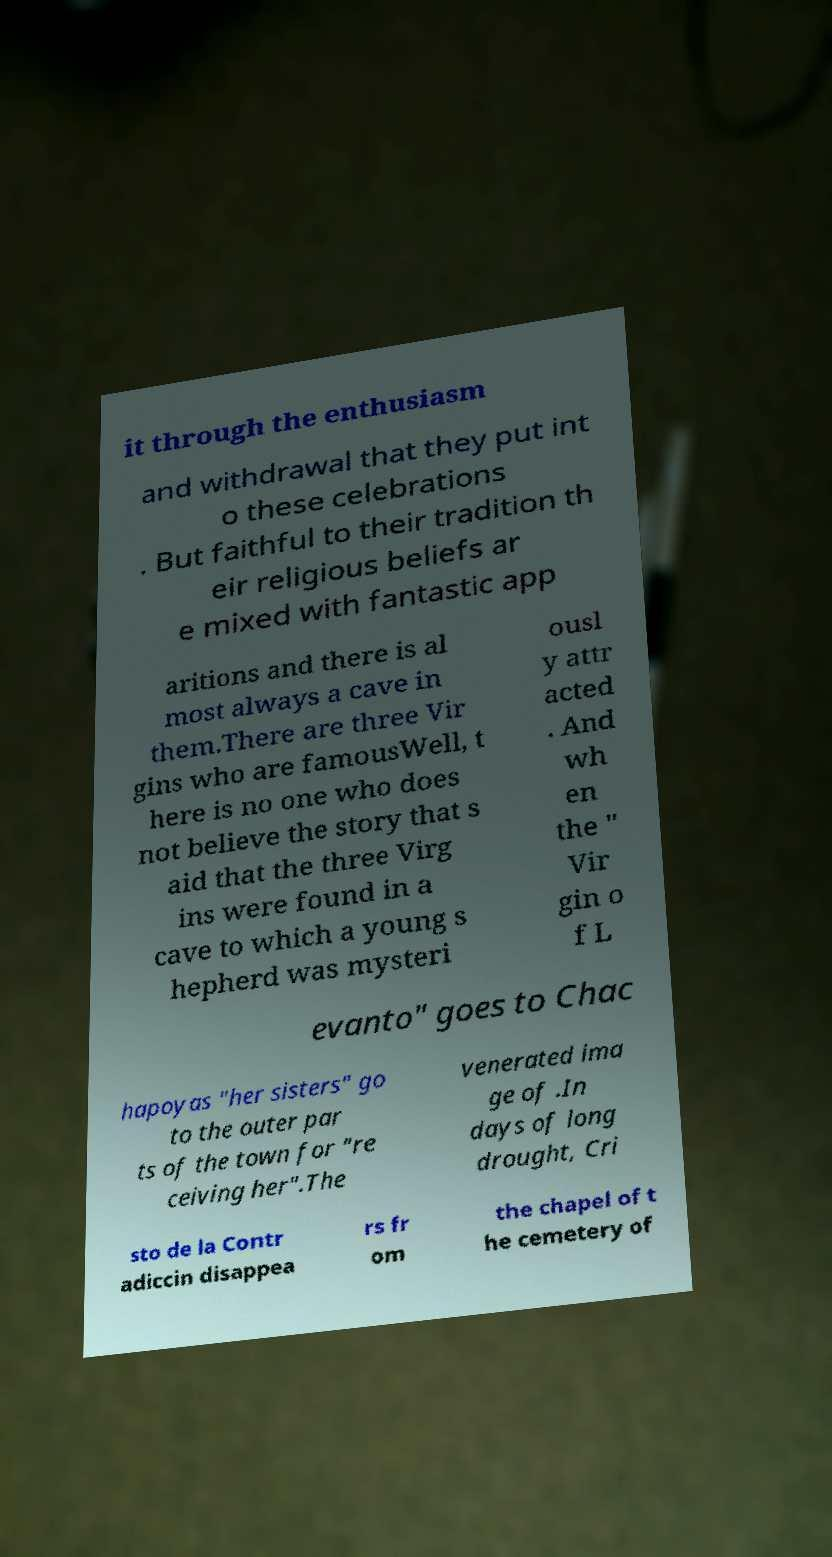Could you assist in decoding the text presented in this image and type it out clearly? it through the enthusiasm and withdrawal that they put int o these celebrations . But faithful to their tradition th eir religious beliefs ar e mixed with fantastic app aritions and there is al most always a cave in them.There are three Vir gins who are famousWell, t here is no one who does not believe the story that s aid that the three Virg ins were found in a cave to which a young s hepherd was mysteri ousl y attr acted . And wh en the " Vir gin o f L evanto" goes to Chac hapoyas "her sisters" go to the outer par ts of the town for "re ceiving her".The venerated ima ge of .In days of long drought, Cri sto de la Contr adiccin disappea rs fr om the chapel of t he cemetery of 